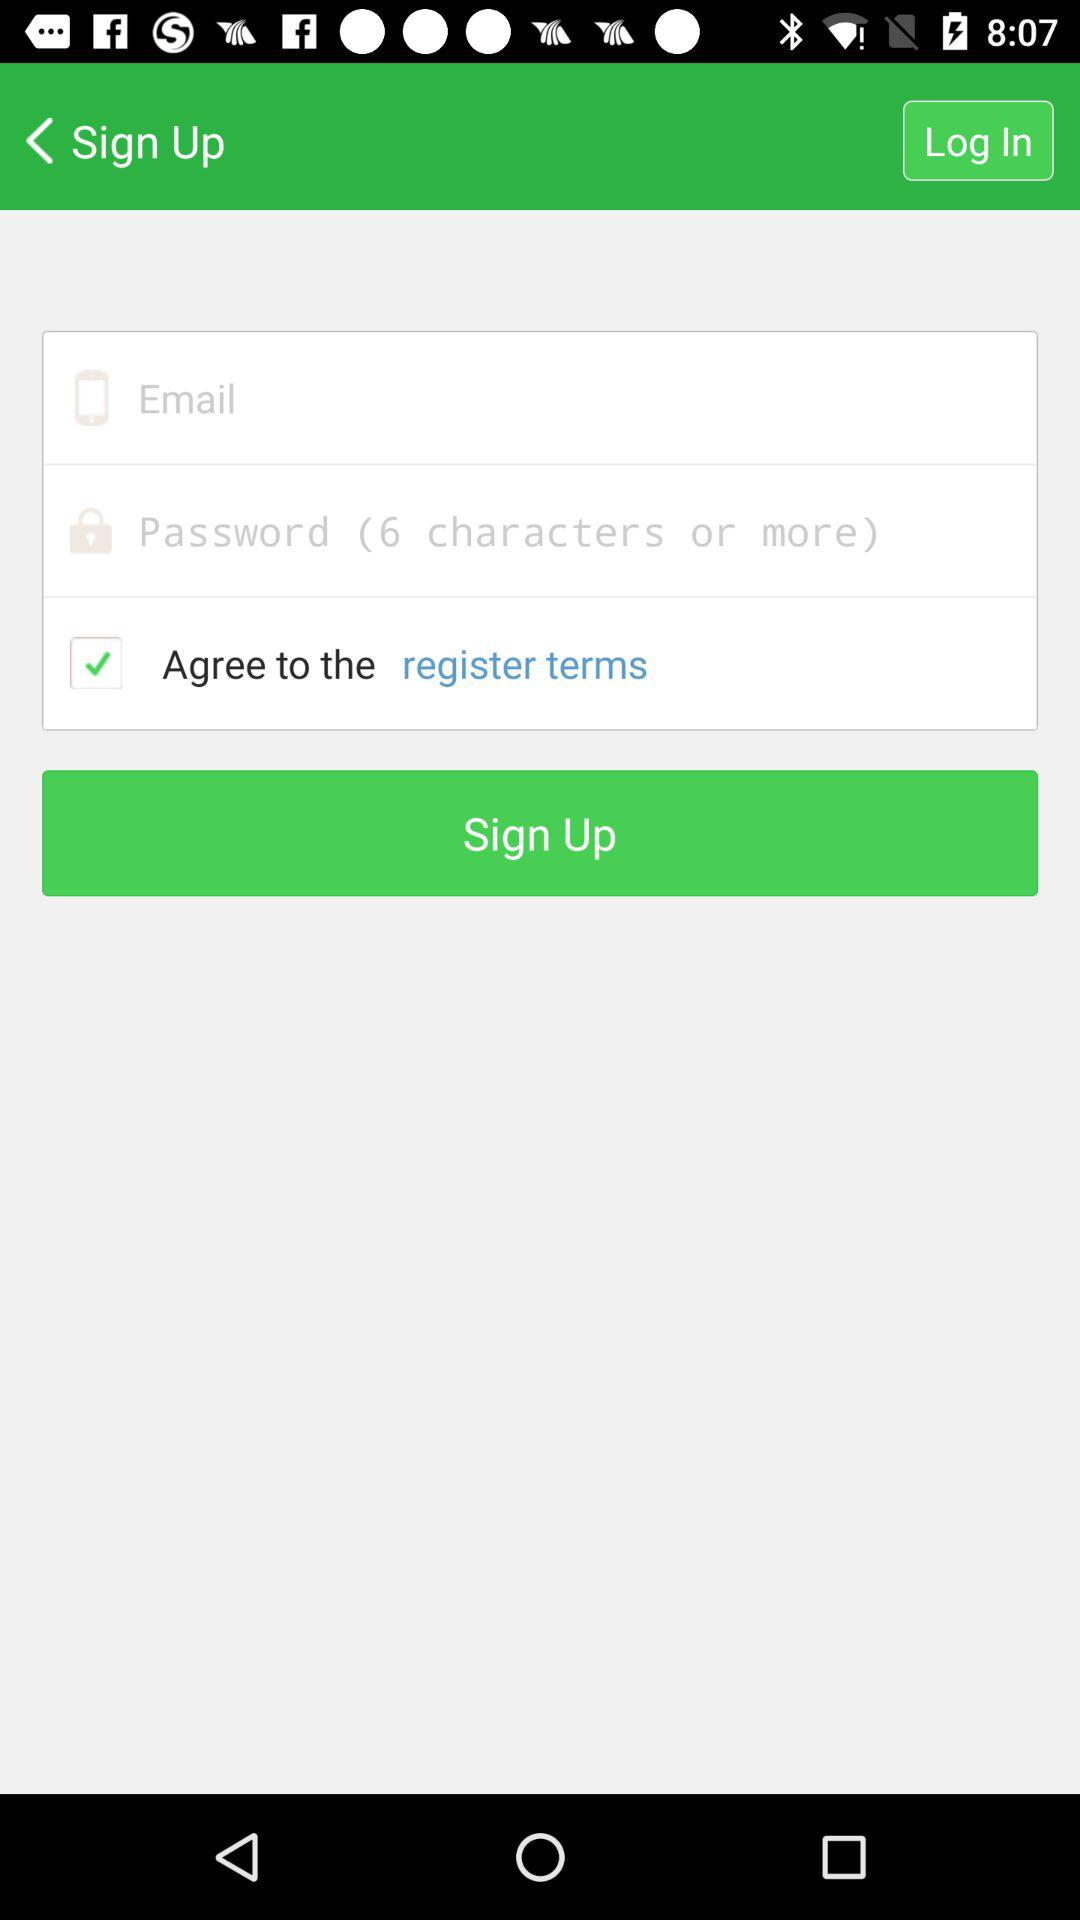What is the required number of characters for the password? The required number of characters for the password is 6 or more. 